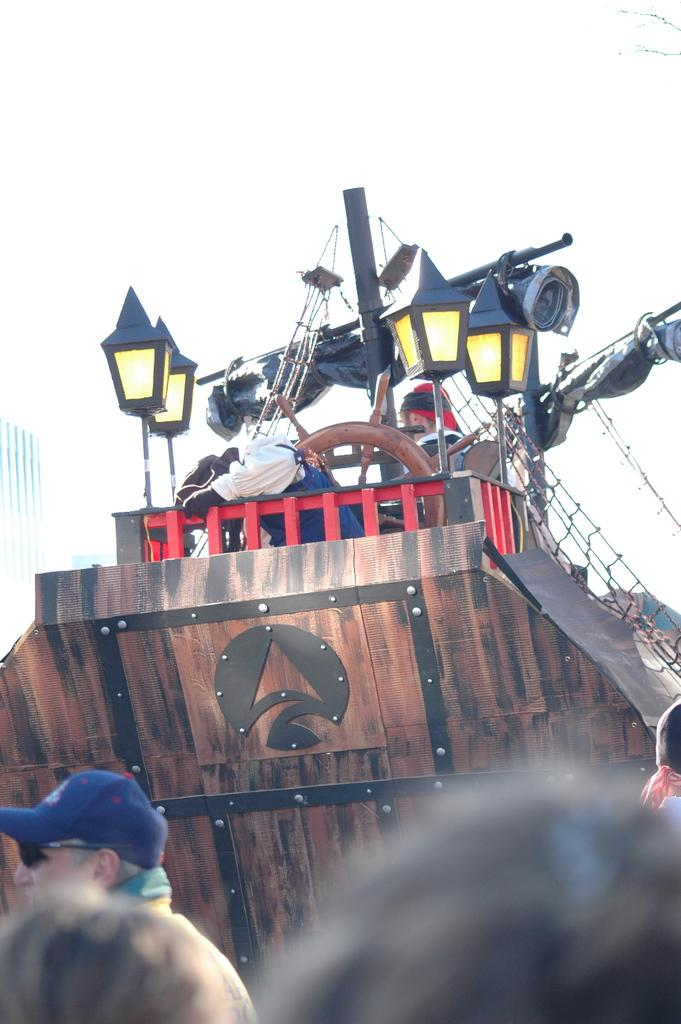Who or what can be seen in the image? There are people and a ship in the image. What features does the ship have? The ship has lights and poles. Are there any people on the ship? Yes, there are persons on the ship. What is present on the ship for catching or holding objects? There is a net on the ship. How does the mom in the image drive the ship? There is no mention of a mom in the image, and the image does not depict anyone driving the ship. 